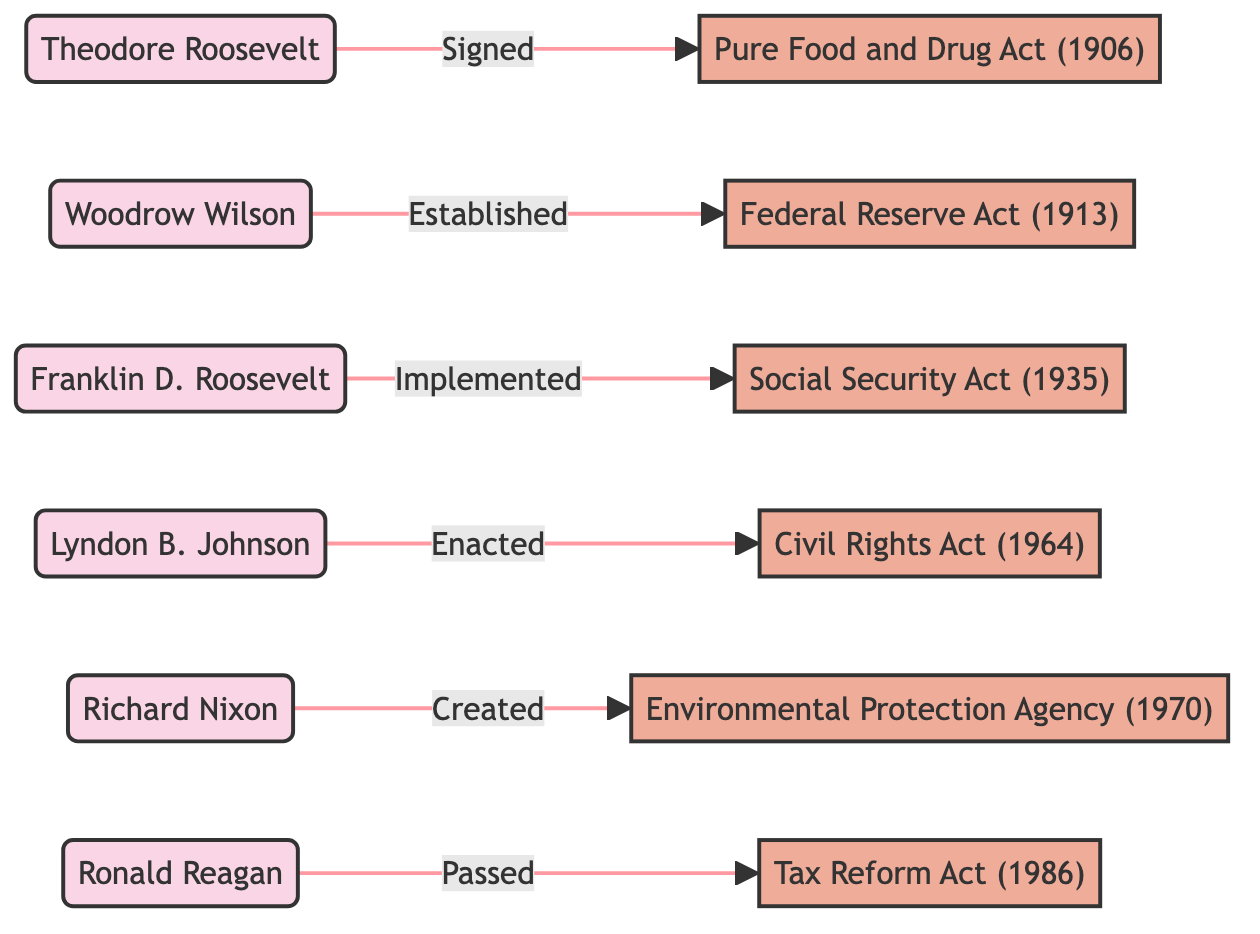What legislation did Theodore Roosevelt sign? The diagram shows a directed edge from Theodore Roosevelt to the Pure Food and Drug Act, indicating he signed this legislation.
Answer: Pure Food and Drug Act (1906) Who established the Federal Reserve Act? The directed edge from Woodrow Wilson to the Federal Reserve Act indicates that he is the one who established this act.
Answer: Woodrow Wilson How many presidents are connected to legislation in the diagram? Counting the distinct nodes labeled as presidents (Theodore Roosevelt, Woodrow Wilson, Franklin D. Roosevelt, Lyndon B. Johnson, Richard Nixon, Ronald Reagan), there are six presidents in total.
Answer: 6 Which president is linked to the Civil Rights Act? The diagram shows a directed edge from Lyndon B. Johnson to the Civil Rights Act, indicating he is the president linked to this legislation.
Answer: Lyndon B. Johnson What is the relationship between Richard Nixon and the Environmental Protection Agency? The directed edge shows that Richard Nixon created the Environmental Protection Agency, indicating a direct historical connection between him and this legislation.
Answer: Created Which legislation was implemented by Franklin D. Roosevelt? According to the diagram, there is a directed edge from Franklin D. Roosevelt to the Social Security Act, indicating he implemented this act.
Answer: Social Security Act (1935) What type of relationship is indicated between Ronald Reagan and the Tax Reform Act? The diagram specifies that Ronald Reagan passed the Tax Reform Act, indicating a legislative action taken by him.
Answer: Passed Which president's legislation was enacted in 1964? The connection in the diagram shows that Lyndon B. Johnson is the president whose legislation, the Civil Rights Act, was enacted in 1964.
Answer: Lyndon B. Johnson 